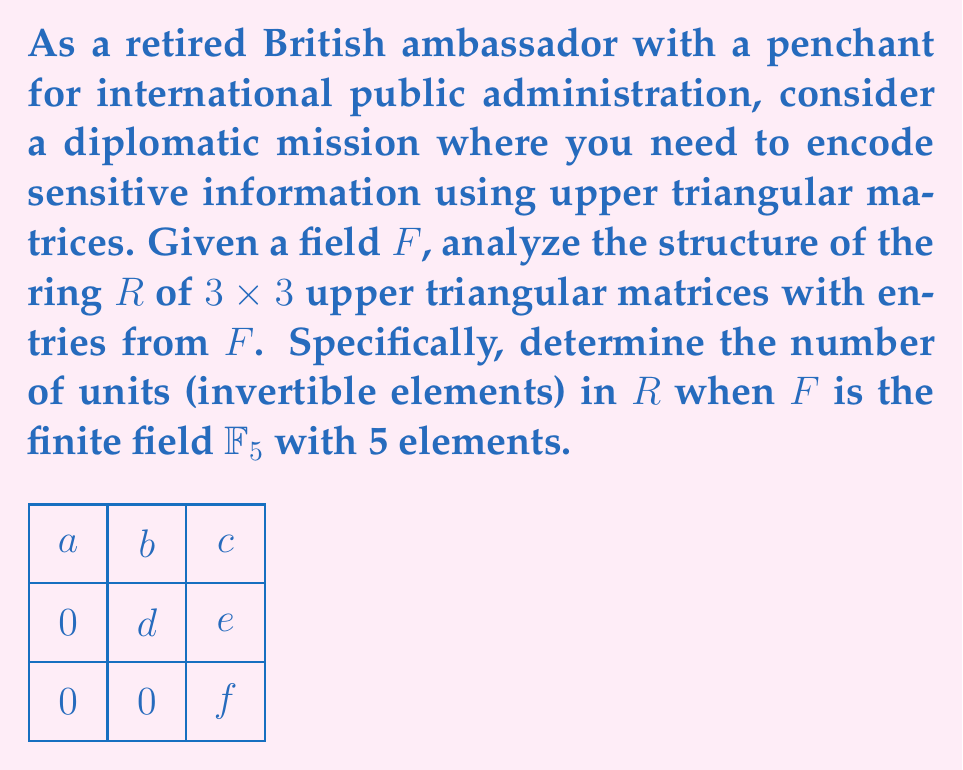Provide a solution to this math problem. Let's approach this step-by-step:

1) First, recall that an upper triangular matrix in $R$ has the form:

   $$\begin{pmatrix}
   a & b & c \\
   0 & d & e \\
   0 & 0 & f
   \end{pmatrix}$$

   where $a, b, c, d, e, f \in \mathbb{F}_5$.

2) For a matrix to be invertible (a unit in the ring), its determinant must be non-zero. The determinant of an upper triangular matrix is the product of its diagonal elements:

   $\det = a \cdot d \cdot f$

3) In $\mathbb{F}_5$, the non-zero elements are 1, 2, 3, and 4. For the matrix to be invertible, each of $a$, $d$, and $f$ must be non-zero.

4) We have 4 choices each for $a$, $d$, and $f$ (any non-zero element in $\mathbb{F}_5$).

5) For $b$, $c$, and $e$, we can choose any element from $\mathbb{F}_5$, including zero. So we have 5 choices each for $b$, $c$, and $e$.

6) By the multiplication principle, the total number of invertible matrices is:

   $4 \cdot 4 \cdot 4 \cdot 5 \cdot 5 \cdot 5 = 4^3 \cdot 5^3 = 64 \cdot 125 = 8000$

Therefore, there are 8000 units in the ring $R$ of 3x3 upper triangular matrices over $\mathbb{F}_5$.
Answer: 8000 